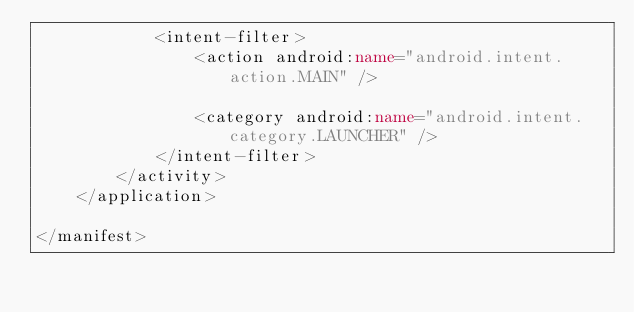<code> <loc_0><loc_0><loc_500><loc_500><_XML_>            <intent-filter>
                <action android:name="android.intent.action.MAIN" />

                <category android:name="android.intent.category.LAUNCHER" />
            </intent-filter>
        </activity>
    </application>

</manifest></code> 